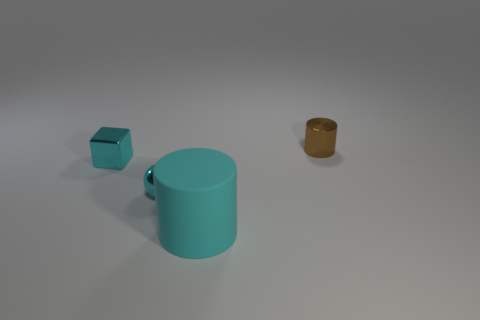Add 2 small shiny spheres. How many objects exist? 6 Subtract 1 cylinders. How many cylinders are left? 1 Subtract all brown cylinders. How many cylinders are left? 1 Subtract all blocks. How many objects are left? 3 Add 1 blue metallic balls. How many blue metallic balls exist? 1 Subtract 0 red blocks. How many objects are left? 4 Subtract all brown spheres. Subtract all brown cylinders. How many spheres are left? 1 Subtract all blue balls. How many green cubes are left? 0 Subtract all tiny green rubber cubes. Subtract all cyan shiny blocks. How many objects are left? 3 Add 3 cyan balls. How many cyan balls are left? 4 